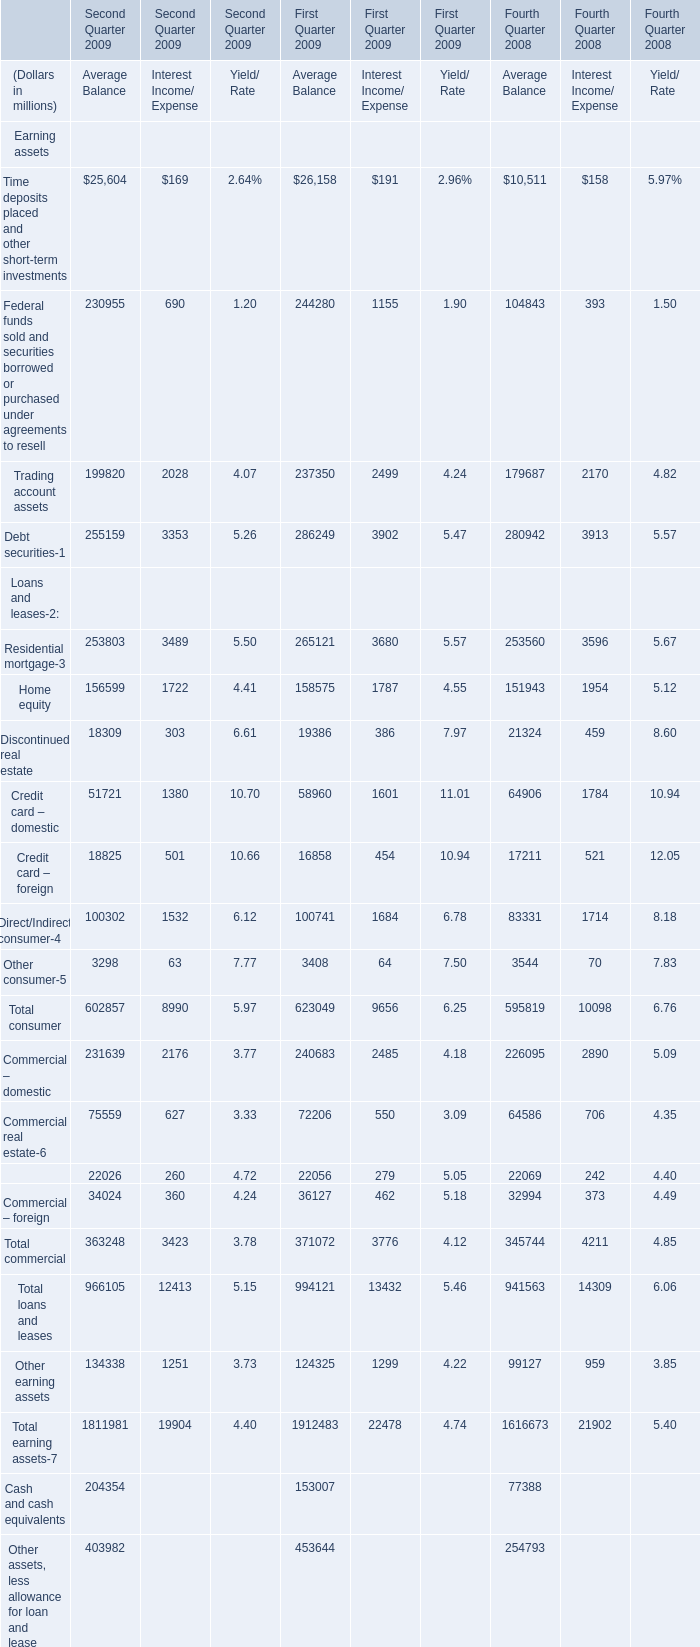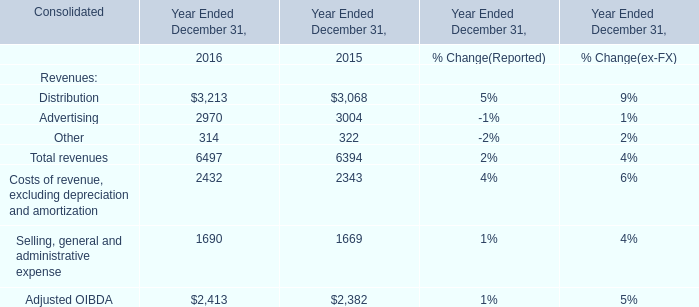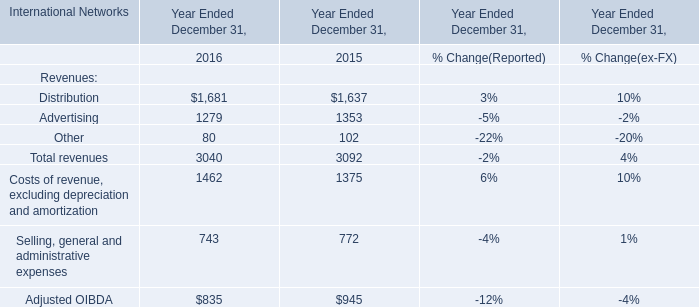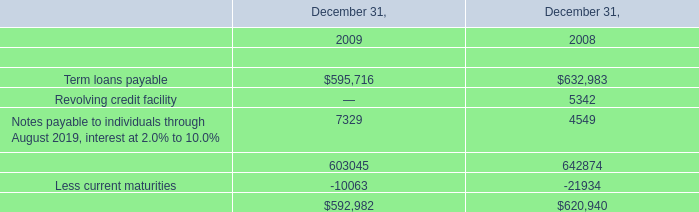What's the average of Less current maturities of December 31, 2008, and Distribution of Year Ended December 31, 2016 ? 
Computations: ((21934.0 + 3213.0) / 2)
Answer: 12573.5. 